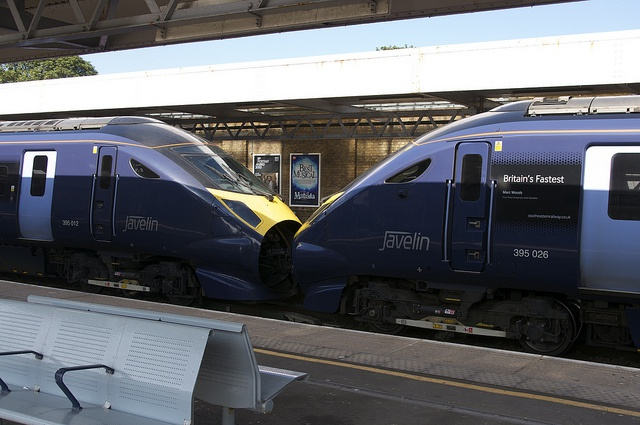Describe the objects in this image and their specific colors. I can see train in black, gray, and white tones, train in black, gray, and darkgray tones, bench in black, darkgray, and gray tones, and bench in black and gray tones in this image. 